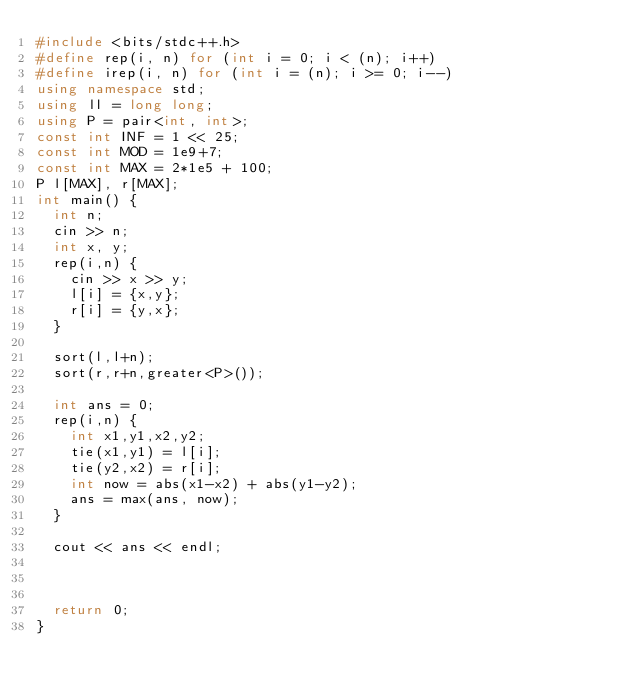<code> <loc_0><loc_0><loc_500><loc_500><_C++_>#include <bits/stdc++.h>
#define rep(i, n) for (int i = 0; i < (n); i++)
#define irep(i, n) for (int i = (n); i >= 0; i--)
using namespace std;
using ll = long long;
using P = pair<int, int>;
const int INF = 1 << 25;
const int MOD = 1e9+7;
const int MAX = 2*1e5 + 100;
P l[MAX], r[MAX];
int main() {
	int n;
	cin >> n;
	int x, y;
	rep(i,n) {
		cin >> x >> y;
		l[i] = {x,y};
		r[i] = {y,x};
	}

	sort(l,l+n);
	sort(r,r+n,greater<P>());

	int ans = 0;
	rep(i,n) {
		int x1,y1,x2,y2;
		tie(x1,y1) = l[i];
		tie(y2,x2) = r[i];
		int now = abs(x1-x2) + abs(y1-y2);
		ans = max(ans, now);
	}

	cout << ans << endl;



	return 0;
}</code> 